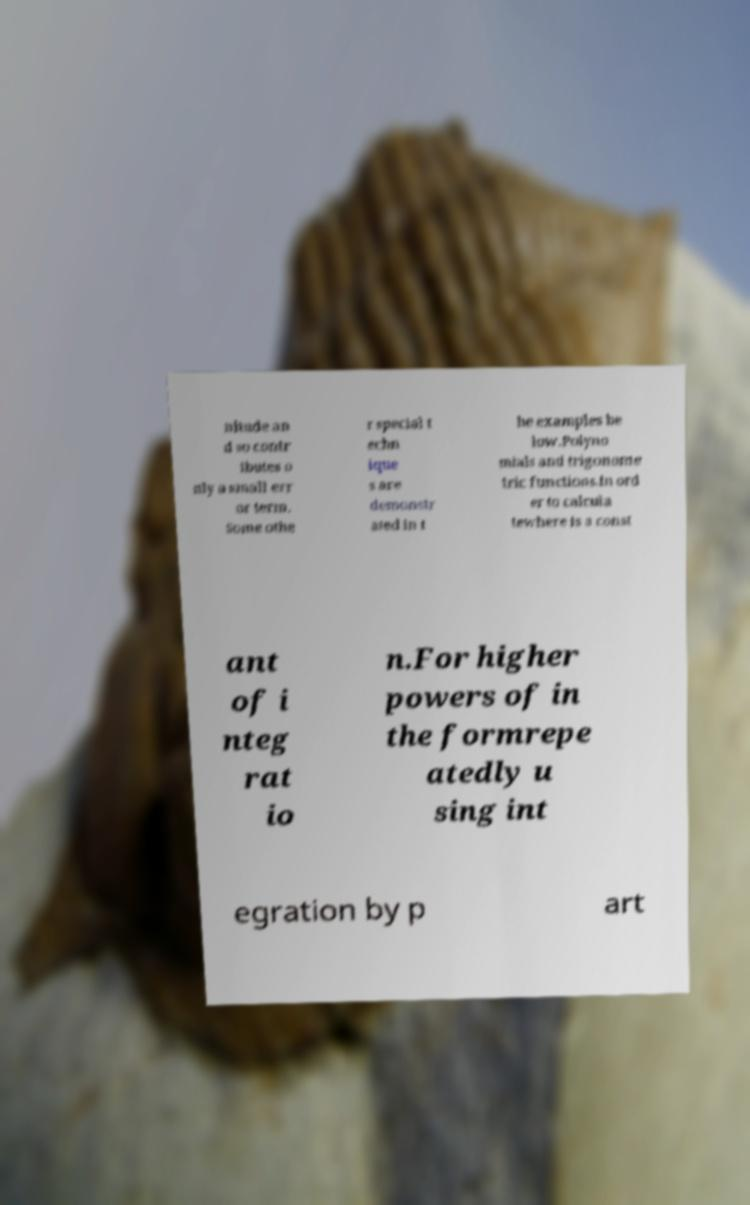Please identify and transcribe the text found in this image. nitude an d so contr ibutes o nly a small err or term. Some othe r special t echn ique s are demonstr ated in t he examples be low.Polyno mials and trigonome tric functions.In ord er to calcula tewhere is a const ant of i nteg rat io n.For higher powers of in the formrepe atedly u sing int egration by p art 